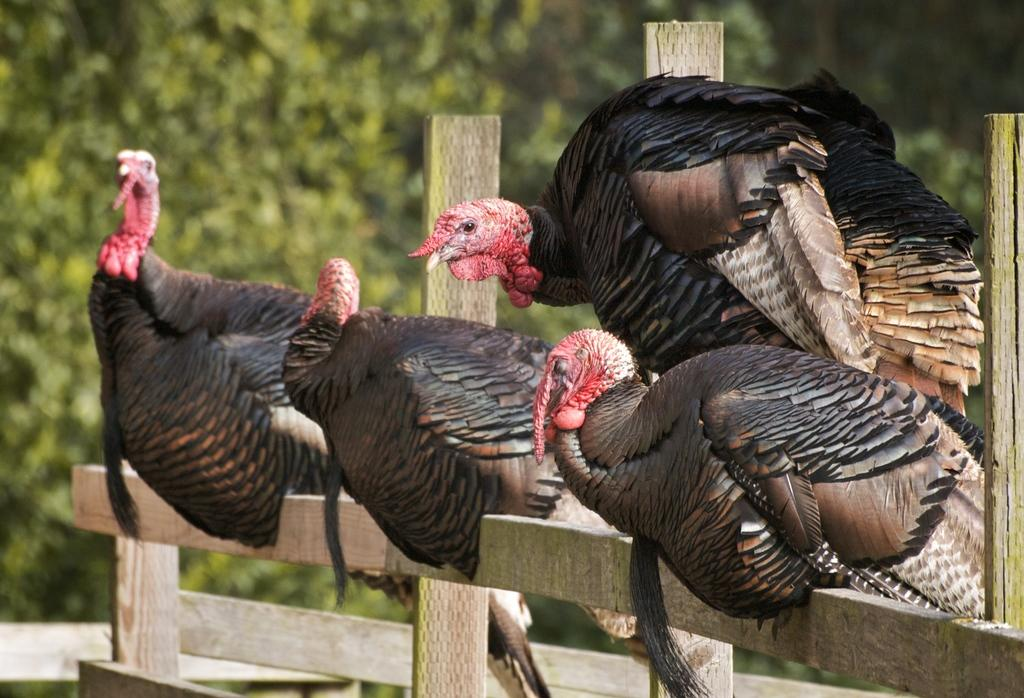How many turkey birds are present in the image? There are four turkey birds in the image. What is the color of the turkey birds? The turkey birds are black in color. Where are the turkey birds sitting in the image? The turkey birds are sitting on a wooden fence. What can be seen in the background of the image? There are trees in the background of the image. What word is written on the fence in the image? There are no words written on the fence in the image; it only shows turkey birds sitting on a wooden fence. 